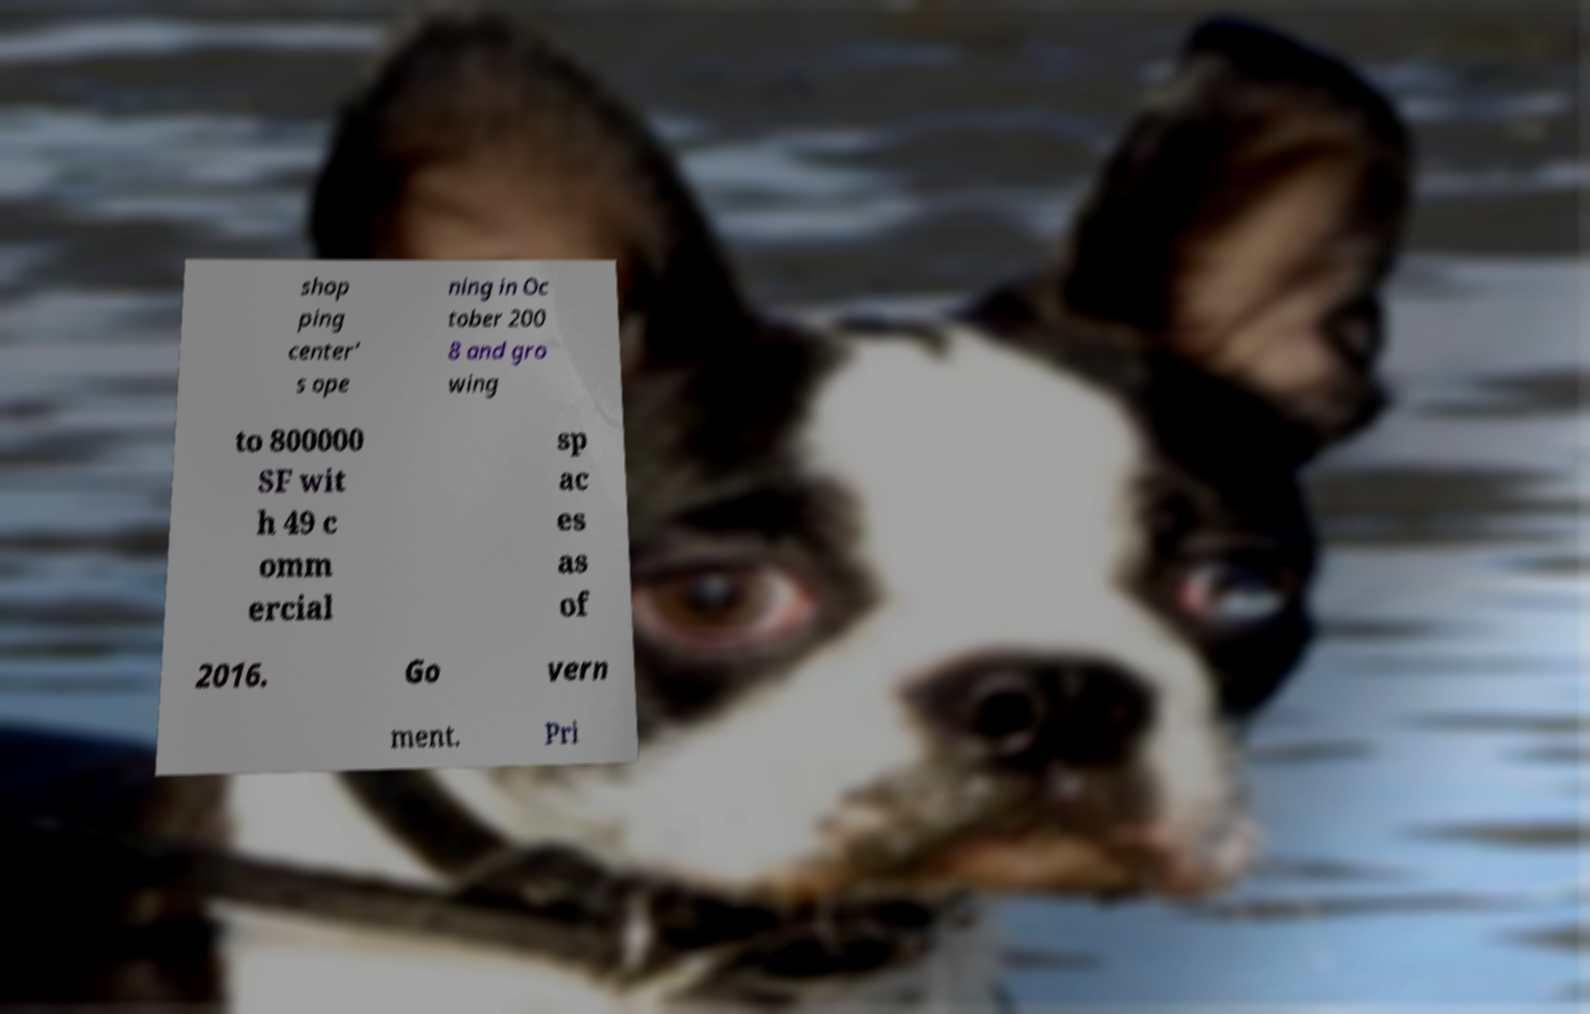Could you extract and type out the text from this image? shop ping center' s ope ning in Oc tober 200 8 and gro wing to 800000 SF wit h 49 c omm ercial sp ac es as of 2016. Go vern ment. Pri 